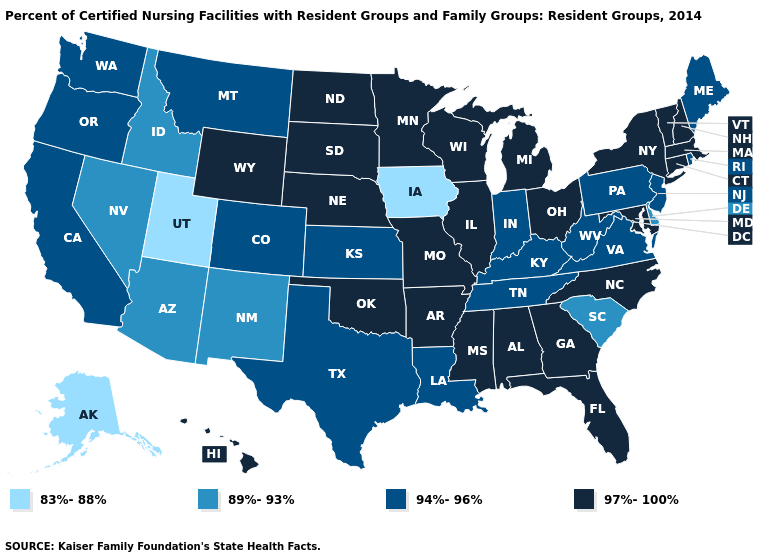What is the value of Massachusetts?
Short answer required. 97%-100%. Does Virginia have the lowest value in the South?
Write a very short answer. No. What is the highest value in the Northeast ?
Give a very brief answer. 97%-100%. Among the states that border New Jersey , which have the highest value?
Concise answer only. New York. What is the value of Colorado?
Be succinct. 94%-96%. How many symbols are there in the legend?
Concise answer only. 4. Name the states that have a value in the range 97%-100%?
Be succinct. Alabama, Arkansas, Connecticut, Florida, Georgia, Hawaii, Illinois, Maryland, Massachusetts, Michigan, Minnesota, Mississippi, Missouri, Nebraska, New Hampshire, New York, North Carolina, North Dakota, Ohio, Oklahoma, South Dakota, Vermont, Wisconsin, Wyoming. What is the highest value in the South ?
Answer briefly. 97%-100%. What is the value of Alaska?
Quick response, please. 83%-88%. What is the value of Colorado?
Short answer required. 94%-96%. Name the states that have a value in the range 83%-88%?
Short answer required. Alaska, Iowa, Utah. Does Kentucky have a higher value than Maine?
Quick response, please. No. How many symbols are there in the legend?
Write a very short answer. 4. What is the highest value in the MidWest ?
Give a very brief answer. 97%-100%. 